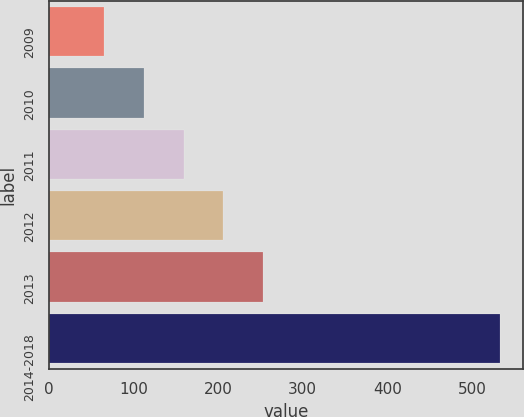Convert chart to OTSL. <chart><loc_0><loc_0><loc_500><loc_500><bar_chart><fcel>2009<fcel>2010<fcel>2011<fcel>2012<fcel>2013<fcel>2014-2018<nl><fcel>65.4<fcel>112.21<fcel>159.02<fcel>205.83<fcel>252.64<fcel>533.5<nl></chart> 